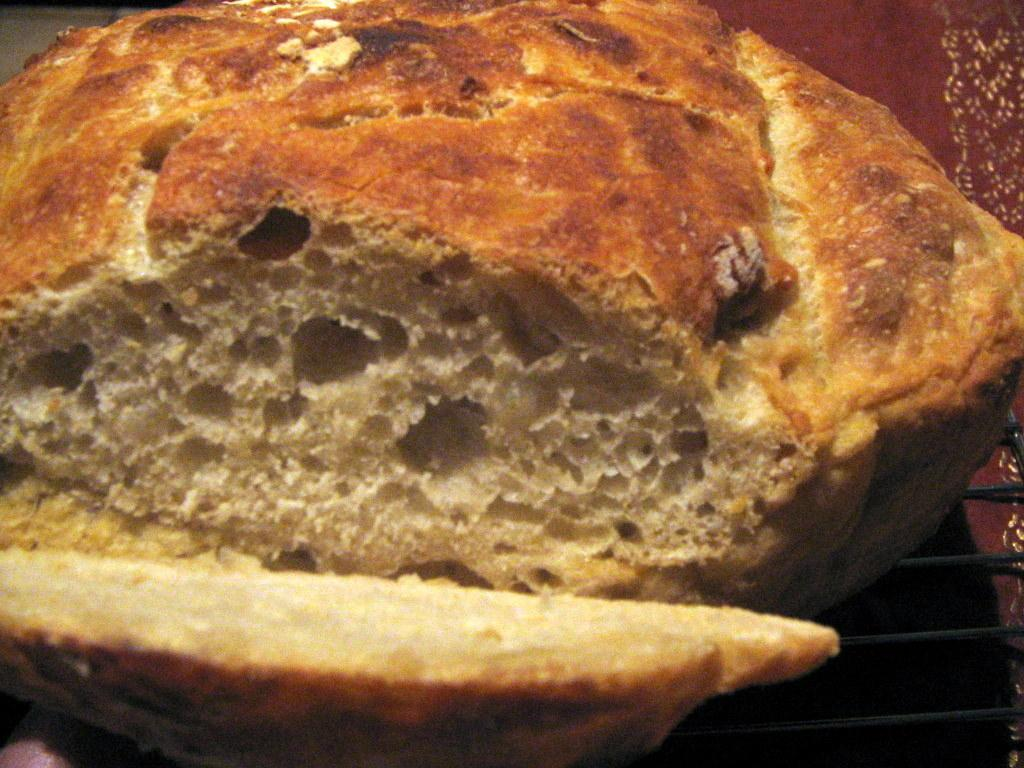What is the main subject of the image? There is a food item in the image. Can you see a rabbit jumping on the roof in the image? There is no mention of a roof or a rabbit in the image, so we cannot confirm their presence. 